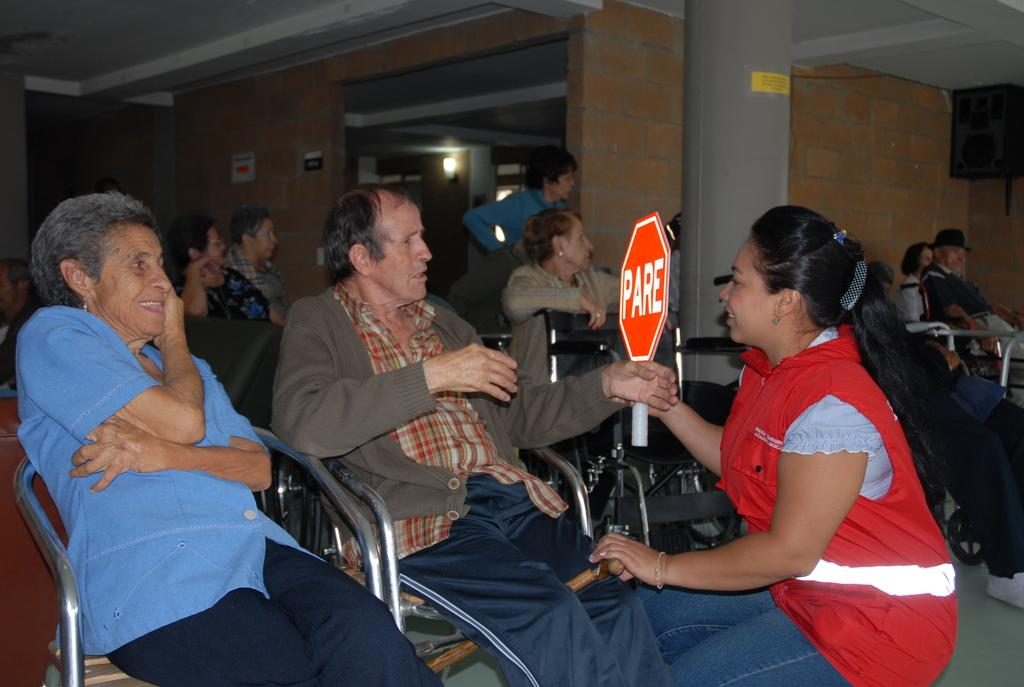What are the people in the image doing? The people in the image are sitting on chairs. What is the woman in the image doing? The woman in the image is talking. What can be seen in the background of the image? There is a pillar, a wall, and a light in the background of the image. What type of surface is visible in the image? The image depicts a floor. What type of jam is being spread on the edge of the sweater in the image? There is no jam or sweater present in the image; it only features people sitting on chairs, a talking woman, and elements in the background. 